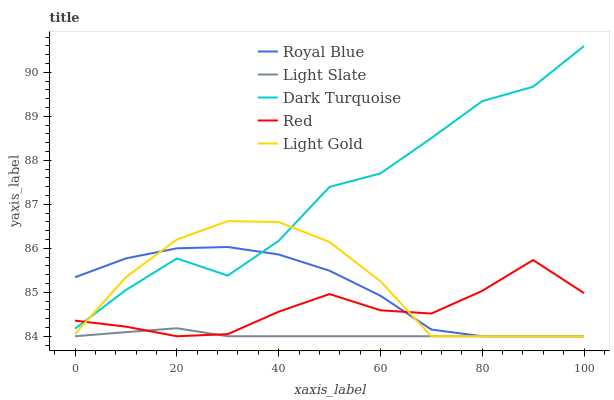Does Light Slate have the minimum area under the curve?
Answer yes or no. Yes. Does Dark Turquoise have the maximum area under the curve?
Answer yes or no. Yes. Does Royal Blue have the minimum area under the curve?
Answer yes or no. No. Does Royal Blue have the maximum area under the curve?
Answer yes or no. No. Is Light Slate the smoothest?
Answer yes or no. Yes. Is Dark Turquoise the roughest?
Answer yes or no. Yes. Is Royal Blue the smoothest?
Answer yes or no. No. Is Royal Blue the roughest?
Answer yes or no. No. Does Light Slate have the lowest value?
Answer yes or no. Yes. Does Dark Turquoise have the lowest value?
Answer yes or no. No. Does Dark Turquoise have the highest value?
Answer yes or no. Yes. Does Royal Blue have the highest value?
Answer yes or no. No. Is Light Slate less than Dark Turquoise?
Answer yes or no. Yes. Is Dark Turquoise greater than Light Slate?
Answer yes or no. Yes. Does Red intersect Light Slate?
Answer yes or no. Yes. Is Red less than Light Slate?
Answer yes or no. No. Is Red greater than Light Slate?
Answer yes or no. No. Does Light Slate intersect Dark Turquoise?
Answer yes or no. No. 